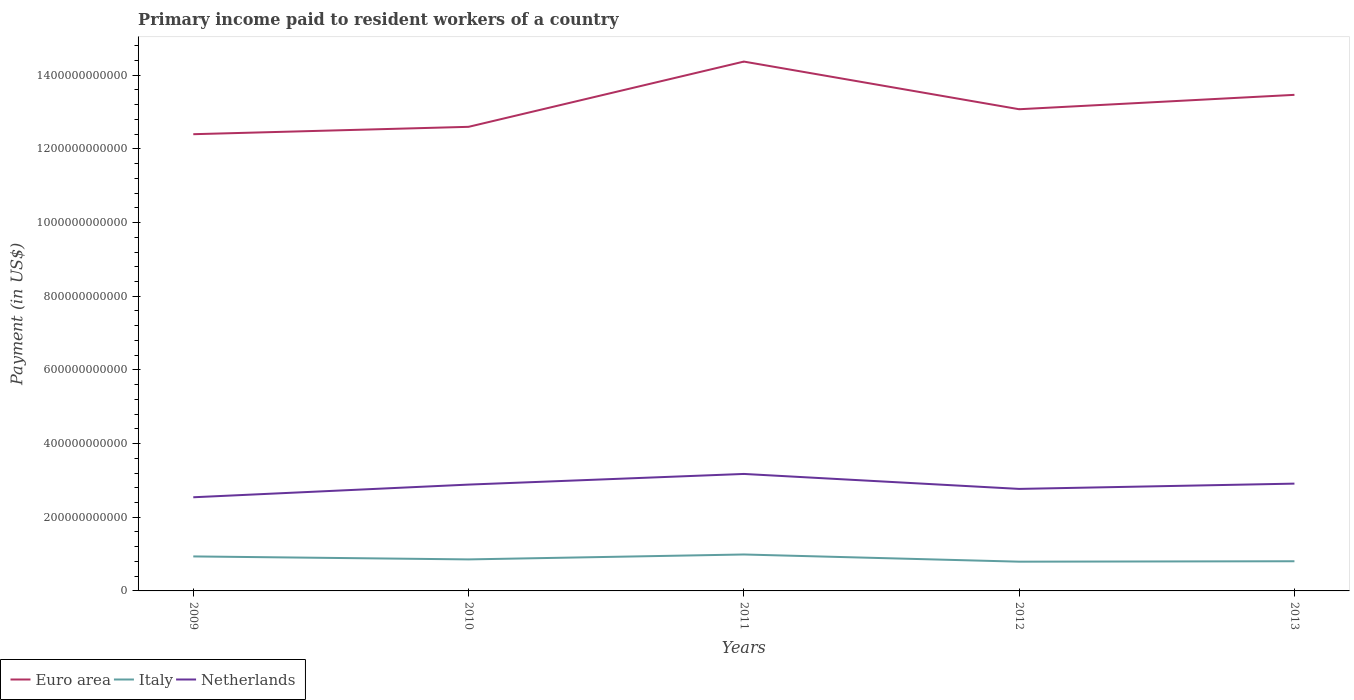Is the number of lines equal to the number of legend labels?
Ensure brevity in your answer.  Yes. Across all years, what is the maximum amount paid to workers in Italy?
Keep it short and to the point. 7.94e+1. What is the total amount paid to workers in Netherlands in the graph?
Offer a terse response. -3.70e+1. What is the difference between the highest and the second highest amount paid to workers in Italy?
Keep it short and to the point. 1.95e+1. What is the difference between the highest and the lowest amount paid to workers in Italy?
Provide a short and direct response. 2. How many lines are there?
Make the answer very short. 3. What is the difference between two consecutive major ticks on the Y-axis?
Make the answer very short. 2.00e+11. Are the values on the major ticks of Y-axis written in scientific E-notation?
Provide a short and direct response. No. Does the graph contain any zero values?
Your answer should be very brief. No. Where does the legend appear in the graph?
Offer a very short reply. Bottom left. How many legend labels are there?
Provide a short and direct response. 3. How are the legend labels stacked?
Your answer should be very brief. Horizontal. What is the title of the graph?
Your response must be concise. Primary income paid to resident workers of a country. What is the label or title of the Y-axis?
Keep it short and to the point. Payment (in US$). What is the Payment (in US$) in Euro area in 2009?
Make the answer very short. 1.24e+12. What is the Payment (in US$) in Italy in 2009?
Your response must be concise. 9.37e+1. What is the Payment (in US$) of Netherlands in 2009?
Offer a terse response. 2.54e+11. What is the Payment (in US$) of Euro area in 2010?
Keep it short and to the point. 1.26e+12. What is the Payment (in US$) in Italy in 2010?
Provide a short and direct response. 8.56e+1. What is the Payment (in US$) in Netherlands in 2010?
Provide a short and direct response. 2.89e+11. What is the Payment (in US$) of Euro area in 2011?
Make the answer very short. 1.44e+12. What is the Payment (in US$) of Italy in 2011?
Your response must be concise. 9.89e+1. What is the Payment (in US$) in Netherlands in 2011?
Ensure brevity in your answer.  3.18e+11. What is the Payment (in US$) in Euro area in 2012?
Give a very brief answer. 1.31e+12. What is the Payment (in US$) of Italy in 2012?
Offer a very short reply. 7.94e+1. What is the Payment (in US$) of Netherlands in 2012?
Your response must be concise. 2.77e+11. What is the Payment (in US$) in Euro area in 2013?
Make the answer very short. 1.35e+12. What is the Payment (in US$) in Italy in 2013?
Your answer should be very brief. 8.06e+1. What is the Payment (in US$) of Netherlands in 2013?
Your answer should be compact. 2.91e+11. Across all years, what is the maximum Payment (in US$) in Euro area?
Offer a very short reply. 1.44e+12. Across all years, what is the maximum Payment (in US$) of Italy?
Ensure brevity in your answer.  9.89e+1. Across all years, what is the maximum Payment (in US$) in Netherlands?
Make the answer very short. 3.18e+11. Across all years, what is the minimum Payment (in US$) in Euro area?
Your answer should be compact. 1.24e+12. Across all years, what is the minimum Payment (in US$) in Italy?
Your answer should be compact. 7.94e+1. Across all years, what is the minimum Payment (in US$) of Netherlands?
Provide a succinct answer. 2.54e+11. What is the total Payment (in US$) of Euro area in the graph?
Ensure brevity in your answer.  6.59e+12. What is the total Payment (in US$) in Italy in the graph?
Your answer should be compact. 4.38e+11. What is the total Payment (in US$) in Netherlands in the graph?
Your answer should be compact. 1.43e+12. What is the difference between the Payment (in US$) in Euro area in 2009 and that in 2010?
Offer a very short reply. -2.00e+1. What is the difference between the Payment (in US$) of Italy in 2009 and that in 2010?
Give a very brief answer. 8.09e+09. What is the difference between the Payment (in US$) in Netherlands in 2009 and that in 2010?
Provide a short and direct response. -3.44e+1. What is the difference between the Payment (in US$) of Euro area in 2009 and that in 2011?
Keep it short and to the point. -1.97e+11. What is the difference between the Payment (in US$) of Italy in 2009 and that in 2011?
Your answer should be very brief. -5.26e+09. What is the difference between the Payment (in US$) of Netherlands in 2009 and that in 2011?
Your answer should be compact. -6.33e+1. What is the difference between the Payment (in US$) in Euro area in 2009 and that in 2012?
Your response must be concise. -6.78e+1. What is the difference between the Payment (in US$) in Italy in 2009 and that in 2012?
Provide a succinct answer. 1.43e+1. What is the difference between the Payment (in US$) of Netherlands in 2009 and that in 2012?
Offer a terse response. -2.27e+1. What is the difference between the Payment (in US$) in Euro area in 2009 and that in 2013?
Your answer should be very brief. -1.07e+11. What is the difference between the Payment (in US$) in Italy in 2009 and that in 2013?
Offer a terse response. 1.31e+1. What is the difference between the Payment (in US$) in Netherlands in 2009 and that in 2013?
Offer a very short reply. -3.70e+1. What is the difference between the Payment (in US$) of Euro area in 2010 and that in 2011?
Your answer should be very brief. -1.77e+11. What is the difference between the Payment (in US$) of Italy in 2010 and that in 2011?
Offer a very short reply. -1.34e+1. What is the difference between the Payment (in US$) of Netherlands in 2010 and that in 2011?
Make the answer very short. -2.89e+1. What is the difference between the Payment (in US$) in Euro area in 2010 and that in 2012?
Offer a terse response. -4.78e+1. What is the difference between the Payment (in US$) in Italy in 2010 and that in 2012?
Keep it short and to the point. 6.16e+09. What is the difference between the Payment (in US$) in Netherlands in 2010 and that in 2012?
Your response must be concise. 1.17e+1. What is the difference between the Payment (in US$) of Euro area in 2010 and that in 2013?
Give a very brief answer. -8.68e+1. What is the difference between the Payment (in US$) of Italy in 2010 and that in 2013?
Offer a very short reply. 5.01e+09. What is the difference between the Payment (in US$) of Netherlands in 2010 and that in 2013?
Provide a short and direct response. -2.66e+09. What is the difference between the Payment (in US$) of Euro area in 2011 and that in 2012?
Make the answer very short. 1.29e+11. What is the difference between the Payment (in US$) of Italy in 2011 and that in 2012?
Give a very brief answer. 1.95e+1. What is the difference between the Payment (in US$) in Netherlands in 2011 and that in 2012?
Provide a succinct answer. 4.06e+1. What is the difference between the Payment (in US$) of Euro area in 2011 and that in 2013?
Offer a terse response. 9.03e+1. What is the difference between the Payment (in US$) in Italy in 2011 and that in 2013?
Your answer should be compact. 1.84e+1. What is the difference between the Payment (in US$) in Netherlands in 2011 and that in 2013?
Give a very brief answer. 2.63e+1. What is the difference between the Payment (in US$) in Euro area in 2012 and that in 2013?
Give a very brief answer. -3.91e+1. What is the difference between the Payment (in US$) in Italy in 2012 and that in 2013?
Your response must be concise. -1.15e+09. What is the difference between the Payment (in US$) in Netherlands in 2012 and that in 2013?
Your answer should be compact. -1.44e+1. What is the difference between the Payment (in US$) of Euro area in 2009 and the Payment (in US$) of Italy in 2010?
Provide a short and direct response. 1.15e+12. What is the difference between the Payment (in US$) in Euro area in 2009 and the Payment (in US$) in Netherlands in 2010?
Make the answer very short. 9.51e+11. What is the difference between the Payment (in US$) in Italy in 2009 and the Payment (in US$) in Netherlands in 2010?
Make the answer very short. -1.95e+11. What is the difference between the Payment (in US$) in Euro area in 2009 and the Payment (in US$) in Italy in 2011?
Ensure brevity in your answer.  1.14e+12. What is the difference between the Payment (in US$) of Euro area in 2009 and the Payment (in US$) of Netherlands in 2011?
Give a very brief answer. 9.22e+11. What is the difference between the Payment (in US$) of Italy in 2009 and the Payment (in US$) of Netherlands in 2011?
Keep it short and to the point. -2.24e+11. What is the difference between the Payment (in US$) in Euro area in 2009 and the Payment (in US$) in Italy in 2012?
Keep it short and to the point. 1.16e+12. What is the difference between the Payment (in US$) in Euro area in 2009 and the Payment (in US$) in Netherlands in 2012?
Give a very brief answer. 9.63e+11. What is the difference between the Payment (in US$) of Italy in 2009 and the Payment (in US$) of Netherlands in 2012?
Provide a short and direct response. -1.83e+11. What is the difference between the Payment (in US$) in Euro area in 2009 and the Payment (in US$) in Italy in 2013?
Offer a terse response. 1.16e+12. What is the difference between the Payment (in US$) of Euro area in 2009 and the Payment (in US$) of Netherlands in 2013?
Ensure brevity in your answer.  9.48e+11. What is the difference between the Payment (in US$) of Italy in 2009 and the Payment (in US$) of Netherlands in 2013?
Provide a succinct answer. -1.98e+11. What is the difference between the Payment (in US$) of Euro area in 2010 and the Payment (in US$) of Italy in 2011?
Make the answer very short. 1.16e+12. What is the difference between the Payment (in US$) in Euro area in 2010 and the Payment (in US$) in Netherlands in 2011?
Offer a terse response. 9.42e+11. What is the difference between the Payment (in US$) in Italy in 2010 and the Payment (in US$) in Netherlands in 2011?
Your answer should be compact. -2.32e+11. What is the difference between the Payment (in US$) in Euro area in 2010 and the Payment (in US$) in Italy in 2012?
Offer a very short reply. 1.18e+12. What is the difference between the Payment (in US$) of Euro area in 2010 and the Payment (in US$) of Netherlands in 2012?
Keep it short and to the point. 9.83e+11. What is the difference between the Payment (in US$) in Italy in 2010 and the Payment (in US$) in Netherlands in 2012?
Provide a short and direct response. -1.91e+11. What is the difference between the Payment (in US$) in Euro area in 2010 and the Payment (in US$) in Italy in 2013?
Ensure brevity in your answer.  1.18e+12. What is the difference between the Payment (in US$) in Euro area in 2010 and the Payment (in US$) in Netherlands in 2013?
Ensure brevity in your answer.  9.69e+11. What is the difference between the Payment (in US$) in Italy in 2010 and the Payment (in US$) in Netherlands in 2013?
Your response must be concise. -2.06e+11. What is the difference between the Payment (in US$) in Euro area in 2011 and the Payment (in US$) in Italy in 2012?
Ensure brevity in your answer.  1.36e+12. What is the difference between the Payment (in US$) in Euro area in 2011 and the Payment (in US$) in Netherlands in 2012?
Provide a succinct answer. 1.16e+12. What is the difference between the Payment (in US$) of Italy in 2011 and the Payment (in US$) of Netherlands in 2012?
Offer a very short reply. -1.78e+11. What is the difference between the Payment (in US$) in Euro area in 2011 and the Payment (in US$) in Italy in 2013?
Keep it short and to the point. 1.36e+12. What is the difference between the Payment (in US$) of Euro area in 2011 and the Payment (in US$) of Netherlands in 2013?
Keep it short and to the point. 1.15e+12. What is the difference between the Payment (in US$) of Italy in 2011 and the Payment (in US$) of Netherlands in 2013?
Provide a succinct answer. -1.92e+11. What is the difference between the Payment (in US$) in Euro area in 2012 and the Payment (in US$) in Italy in 2013?
Provide a short and direct response. 1.23e+12. What is the difference between the Payment (in US$) in Euro area in 2012 and the Payment (in US$) in Netherlands in 2013?
Offer a very short reply. 1.02e+12. What is the difference between the Payment (in US$) in Italy in 2012 and the Payment (in US$) in Netherlands in 2013?
Ensure brevity in your answer.  -2.12e+11. What is the average Payment (in US$) of Euro area per year?
Offer a terse response. 1.32e+12. What is the average Payment (in US$) in Italy per year?
Keep it short and to the point. 8.76e+1. What is the average Payment (in US$) of Netherlands per year?
Offer a very short reply. 2.86e+11. In the year 2009, what is the difference between the Payment (in US$) in Euro area and Payment (in US$) in Italy?
Your answer should be compact. 1.15e+12. In the year 2009, what is the difference between the Payment (in US$) in Euro area and Payment (in US$) in Netherlands?
Provide a short and direct response. 9.86e+11. In the year 2009, what is the difference between the Payment (in US$) in Italy and Payment (in US$) in Netherlands?
Your response must be concise. -1.61e+11. In the year 2010, what is the difference between the Payment (in US$) in Euro area and Payment (in US$) in Italy?
Provide a short and direct response. 1.17e+12. In the year 2010, what is the difference between the Payment (in US$) in Euro area and Payment (in US$) in Netherlands?
Provide a succinct answer. 9.71e+11. In the year 2010, what is the difference between the Payment (in US$) in Italy and Payment (in US$) in Netherlands?
Make the answer very short. -2.03e+11. In the year 2011, what is the difference between the Payment (in US$) of Euro area and Payment (in US$) of Italy?
Provide a succinct answer. 1.34e+12. In the year 2011, what is the difference between the Payment (in US$) of Euro area and Payment (in US$) of Netherlands?
Offer a terse response. 1.12e+12. In the year 2011, what is the difference between the Payment (in US$) of Italy and Payment (in US$) of Netherlands?
Your answer should be compact. -2.19e+11. In the year 2012, what is the difference between the Payment (in US$) in Euro area and Payment (in US$) in Italy?
Your answer should be very brief. 1.23e+12. In the year 2012, what is the difference between the Payment (in US$) of Euro area and Payment (in US$) of Netherlands?
Your answer should be compact. 1.03e+12. In the year 2012, what is the difference between the Payment (in US$) of Italy and Payment (in US$) of Netherlands?
Provide a succinct answer. -1.98e+11. In the year 2013, what is the difference between the Payment (in US$) in Euro area and Payment (in US$) in Italy?
Ensure brevity in your answer.  1.27e+12. In the year 2013, what is the difference between the Payment (in US$) in Euro area and Payment (in US$) in Netherlands?
Offer a terse response. 1.06e+12. In the year 2013, what is the difference between the Payment (in US$) in Italy and Payment (in US$) in Netherlands?
Provide a short and direct response. -2.11e+11. What is the ratio of the Payment (in US$) of Euro area in 2009 to that in 2010?
Offer a very short reply. 0.98. What is the ratio of the Payment (in US$) of Italy in 2009 to that in 2010?
Offer a terse response. 1.09. What is the ratio of the Payment (in US$) of Netherlands in 2009 to that in 2010?
Give a very brief answer. 0.88. What is the ratio of the Payment (in US$) of Euro area in 2009 to that in 2011?
Provide a short and direct response. 0.86. What is the ratio of the Payment (in US$) of Italy in 2009 to that in 2011?
Offer a very short reply. 0.95. What is the ratio of the Payment (in US$) in Netherlands in 2009 to that in 2011?
Make the answer very short. 0.8. What is the ratio of the Payment (in US$) in Euro area in 2009 to that in 2012?
Offer a very short reply. 0.95. What is the ratio of the Payment (in US$) in Italy in 2009 to that in 2012?
Your response must be concise. 1.18. What is the ratio of the Payment (in US$) in Netherlands in 2009 to that in 2012?
Offer a very short reply. 0.92. What is the ratio of the Payment (in US$) in Euro area in 2009 to that in 2013?
Keep it short and to the point. 0.92. What is the ratio of the Payment (in US$) of Italy in 2009 to that in 2013?
Offer a terse response. 1.16. What is the ratio of the Payment (in US$) of Netherlands in 2009 to that in 2013?
Your response must be concise. 0.87. What is the ratio of the Payment (in US$) of Euro area in 2010 to that in 2011?
Ensure brevity in your answer.  0.88. What is the ratio of the Payment (in US$) in Italy in 2010 to that in 2011?
Make the answer very short. 0.86. What is the ratio of the Payment (in US$) of Netherlands in 2010 to that in 2011?
Keep it short and to the point. 0.91. What is the ratio of the Payment (in US$) in Euro area in 2010 to that in 2012?
Your answer should be compact. 0.96. What is the ratio of the Payment (in US$) of Italy in 2010 to that in 2012?
Make the answer very short. 1.08. What is the ratio of the Payment (in US$) of Netherlands in 2010 to that in 2012?
Provide a succinct answer. 1.04. What is the ratio of the Payment (in US$) of Euro area in 2010 to that in 2013?
Keep it short and to the point. 0.94. What is the ratio of the Payment (in US$) of Italy in 2010 to that in 2013?
Your answer should be very brief. 1.06. What is the ratio of the Payment (in US$) in Netherlands in 2010 to that in 2013?
Your answer should be very brief. 0.99. What is the ratio of the Payment (in US$) in Euro area in 2011 to that in 2012?
Offer a terse response. 1.1. What is the ratio of the Payment (in US$) in Italy in 2011 to that in 2012?
Offer a very short reply. 1.25. What is the ratio of the Payment (in US$) of Netherlands in 2011 to that in 2012?
Your answer should be compact. 1.15. What is the ratio of the Payment (in US$) in Euro area in 2011 to that in 2013?
Give a very brief answer. 1.07. What is the ratio of the Payment (in US$) in Italy in 2011 to that in 2013?
Provide a short and direct response. 1.23. What is the ratio of the Payment (in US$) of Netherlands in 2011 to that in 2013?
Provide a succinct answer. 1.09. What is the ratio of the Payment (in US$) in Euro area in 2012 to that in 2013?
Make the answer very short. 0.97. What is the ratio of the Payment (in US$) in Italy in 2012 to that in 2013?
Offer a very short reply. 0.99. What is the ratio of the Payment (in US$) in Netherlands in 2012 to that in 2013?
Your answer should be very brief. 0.95. What is the difference between the highest and the second highest Payment (in US$) in Euro area?
Your response must be concise. 9.03e+1. What is the difference between the highest and the second highest Payment (in US$) in Italy?
Offer a terse response. 5.26e+09. What is the difference between the highest and the second highest Payment (in US$) of Netherlands?
Your answer should be very brief. 2.63e+1. What is the difference between the highest and the lowest Payment (in US$) in Euro area?
Provide a short and direct response. 1.97e+11. What is the difference between the highest and the lowest Payment (in US$) of Italy?
Offer a terse response. 1.95e+1. What is the difference between the highest and the lowest Payment (in US$) in Netherlands?
Offer a very short reply. 6.33e+1. 